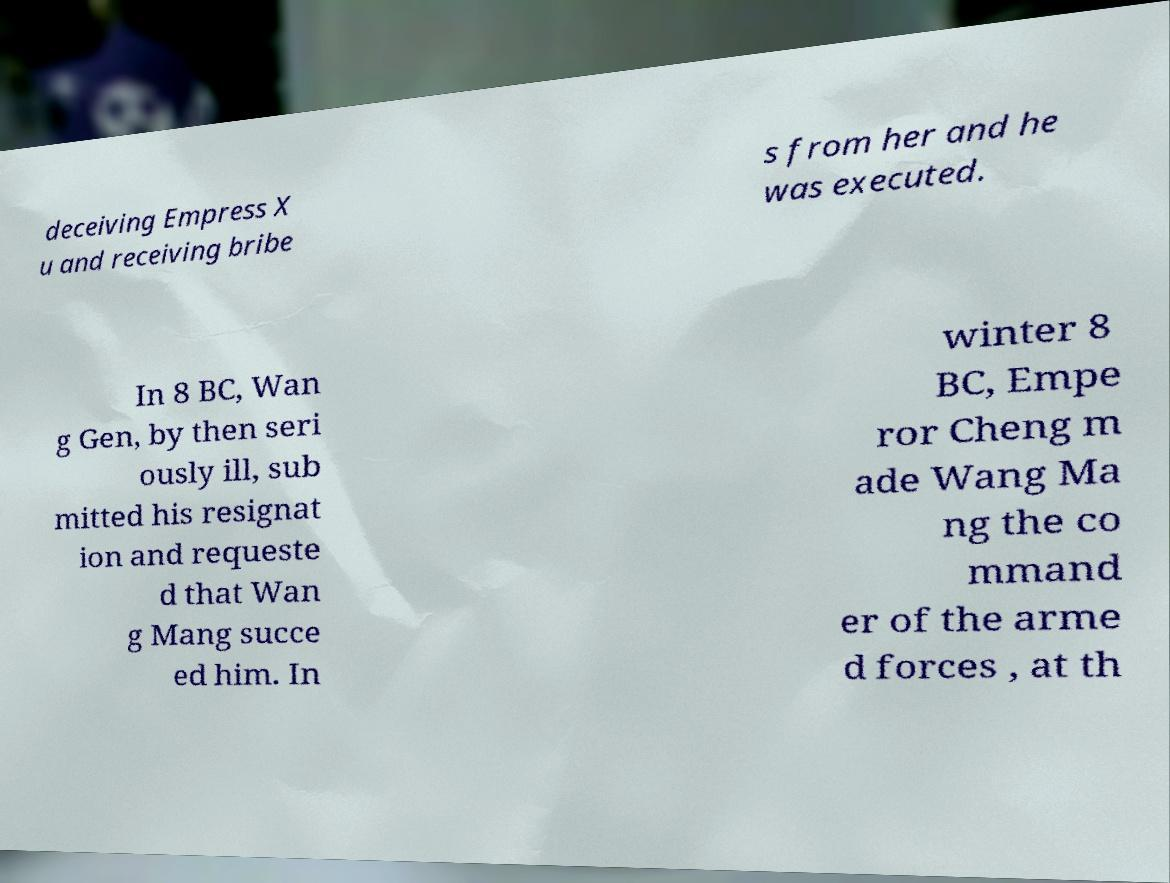What messages or text are displayed in this image? I need them in a readable, typed format. deceiving Empress X u and receiving bribe s from her and he was executed. In 8 BC, Wan g Gen, by then seri ously ill, sub mitted his resignat ion and requeste d that Wan g Mang succe ed him. In winter 8 BC, Empe ror Cheng m ade Wang Ma ng the co mmand er of the arme d forces , at th 